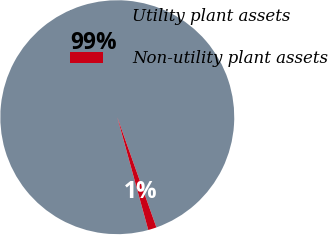Convert chart. <chart><loc_0><loc_0><loc_500><loc_500><pie_chart><fcel>Utility plant assets<fcel>Non-utility plant assets<nl><fcel>98.84%<fcel>1.16%<nl></chart> 